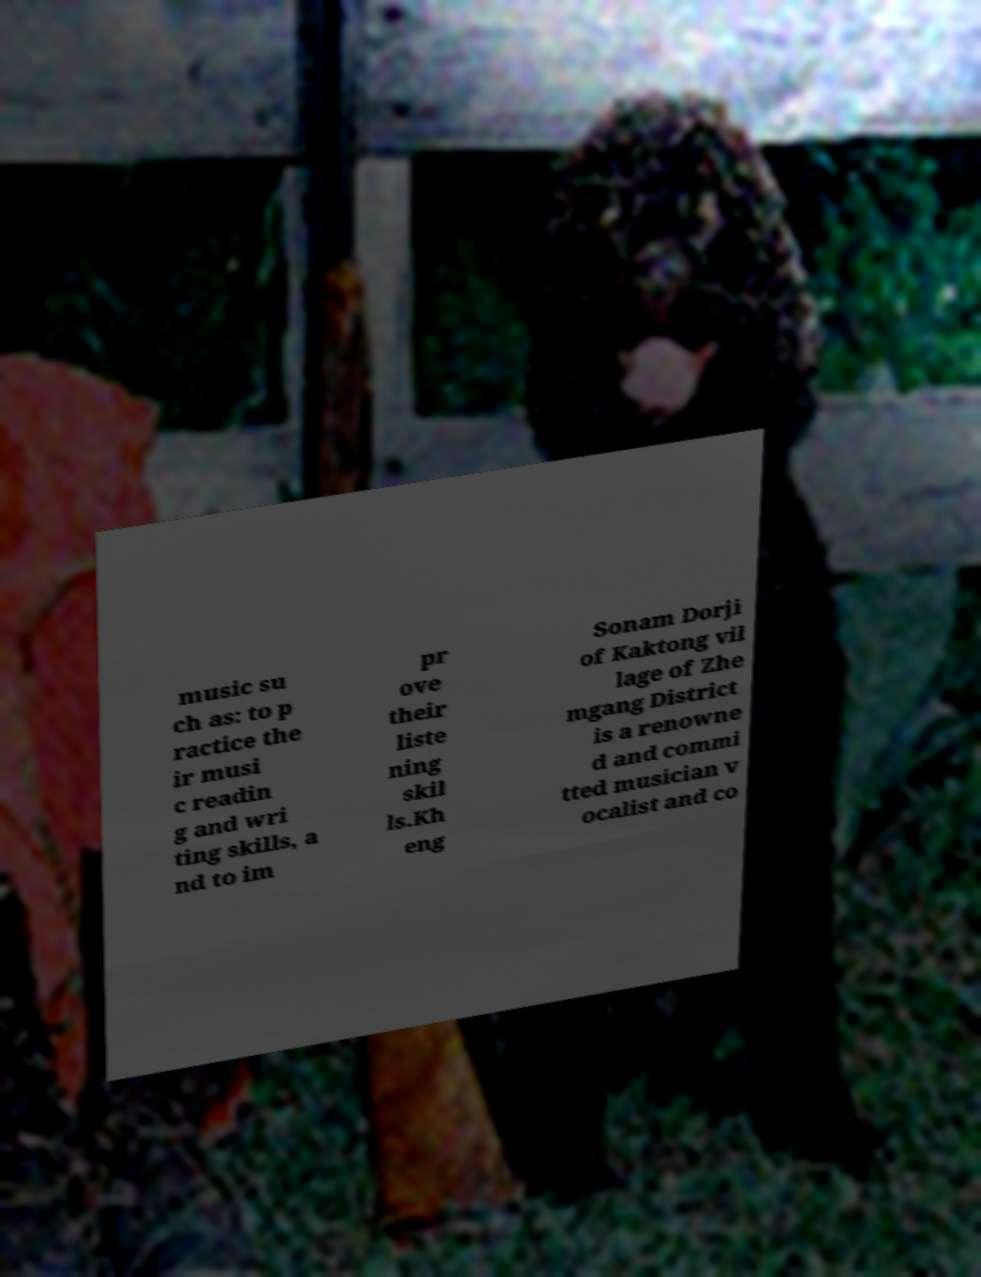Could you extract and type out the text from this image? music su ch as: to p ractice the ir musi c readin g and wri ting skills, a nd to im pr ove their liste ning skil ls.Kh eng Sonam Dorji of Kaktong vil lage of Zhe mgang District is a renowne d and commi tted musician v ocalist and co 